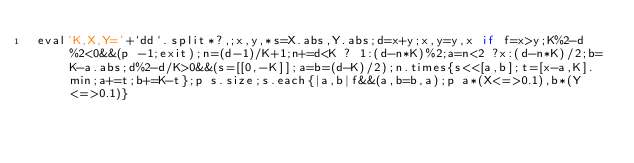Convert code to text. <code><loc_0><loc_0><loc_500><loc_500><_Ruby_>eval'K,X,Y='+`dd`.split*?,;x,y,*s=X.abs,Y.abs;d=x+y;x,y=y,x if f=x>y;K%2-d%2<0&&(p -1;exit);n=(d-1)/K+1;n+=d<K ? 1:(d-n*K)%2;a=n<2 ?x:(d-n*K)/2;b=K-a.abs;d%2-d/K>0&&(s=[[0,-K]];a=b=(d-K)/2);n.times{s<<[a,b];t=[x-a,K].min;a+=t;b+=K-t};p s.size;s.each{|a,b|f&&(a,b=b,a);p a*(X<=>0.1),b*(Y<=>0.1)}</code> 